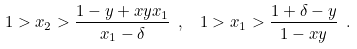Convert formula to latex. <formula><loc_0><loc_0><loc_500><loc_500>1 > x _ { 2 } > \frac { 1 - y + x y x _ { 1 } } { x _ { 1 } - \delta } \ , \ \ 1 > x _ { 1 } > \frac { 1 + \delta - y } { 1 - x y } \ .</formula> 